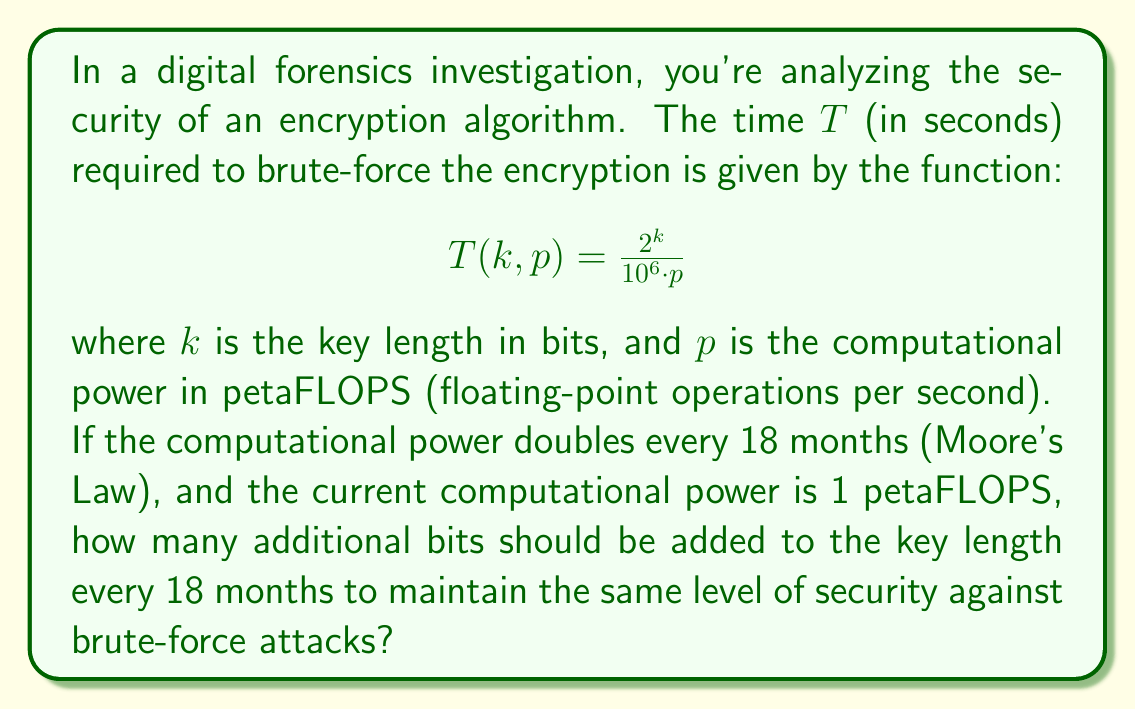Teach me how to tackle this problem. Let's approach this step-by-step:

1) First, we need to understand what "maintaining the same level of security" means. It means keeping $T$ constant as $p$ increases and $k$ changes.

2) Let's say after 18 months, the new key length is $k + x$, where $x$ is the number of additional bits we need to find.

3) The new computational power after 18 months will be $2p$ (doubled).

4) For the security level to remain the same, we must have:

   $$\frac{2^k}{10^6 \cdot p} = \frac{2^{k+x}}{10^6 \cdot 2p}$$

5) Simplifying the right side:

   $$\frac{2^k}{10^6 \cdot p} = \frac{2^k \cdot 2^x}{10^6 \cdot 2p} = \frac{2^k \cdot 2^x}{2 \cdot 10^6 \cdot p}$$

6) For these to be equal:

   $$2^x = 2$$

7) Taking the logarithm of both sides:

   $$x \log_2(2) = \log_2(2)$$

8) Simplify:

   $$x = 1$$

Therefore, adding 1 bit to the key length every 18 months will maintain the same level of security against brute-force attacks.
Answer: 1 bit 